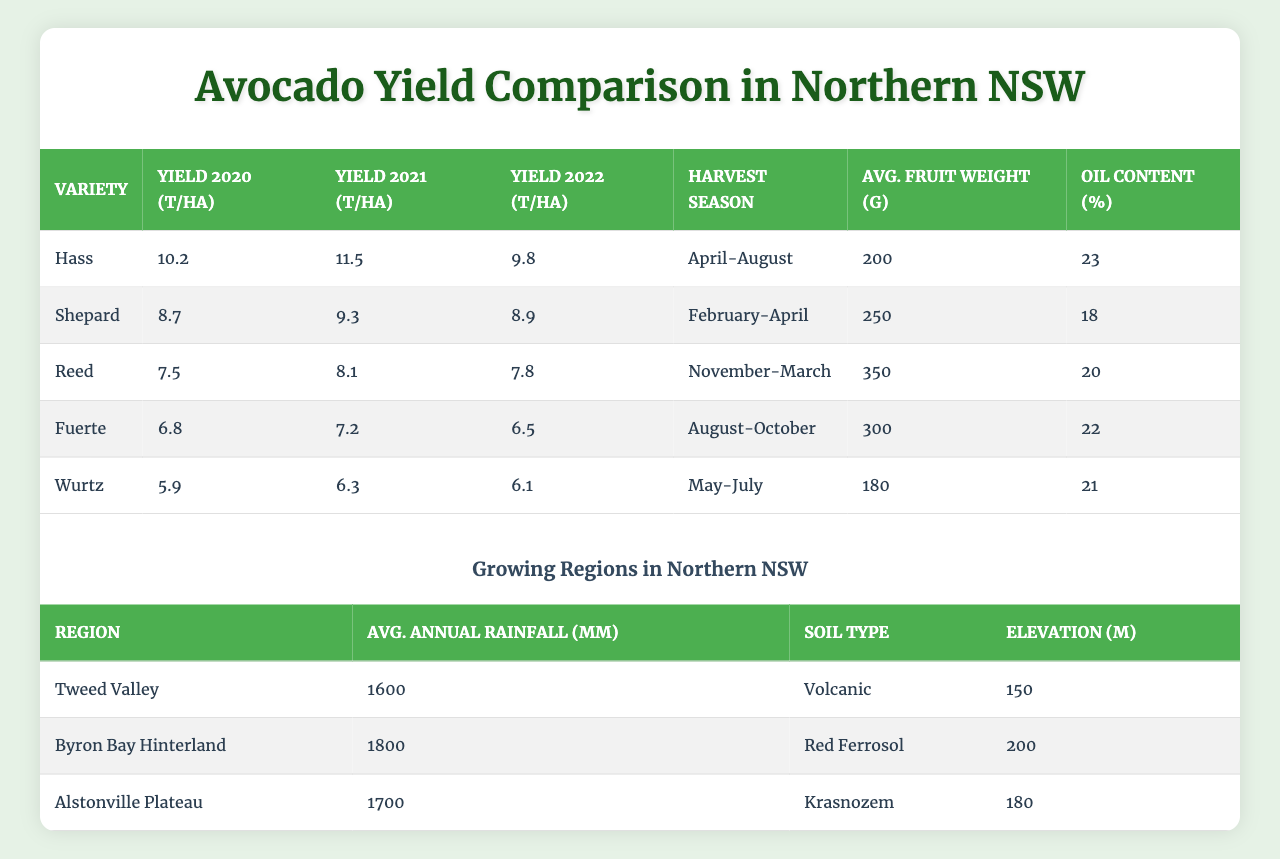What is the yield of the Hass variety in 2021? The table indicates the yield of the Hass variety for 2021 is 11.5 tonnes per hectare.
Answer: 11.5 tonnes per hectare Which variety has the highest average fruit weight? By comparing the average fruit weights in the table, Reed has the highest average fruit weight of 350 grams.
Answer: Reed What is the average yield of the Shepard variety over the three years? To find the average yield of the Shepard variety, we sum the yields for 2020, 2021, and 2022, which is (8.7 + 9.3 + 8.9) = 26.9. Then, we divide by 3 to get the average: 26.9 / 3 = 8.97 tonnes per hectare.
Answer: 8.97 tonnes per hectare Is the oil content of Fuerte avocado higher than that of Shepard? The oil content of Fuerte is 22%, while that of Shepard is 18%. Since 22% is greater than 18%, the statement is true.
Answer: Yes Which avocado variety had the lowest yield in 2022? By looking at the yields for 2022 in the table, Wurtz had the lowest yield of 6.1 tonnes per hectare.
Answer: Wurtz What is the difference in yield between Hass and Fuerte in 2020? The yield of Hass in 2020 was 10.2 tonnes per hectare, while Fuerte had 6.8 tonnes per hectare. The difference is 10.2 - 6.8 = 3.4 tonnes per hectare.
Answer: 3.4 tonnes per hectare Which region has the highest average annual rainfall? Comparing the average annual rainfall in the table, Byron Bay Hinterland has the highest rainfall at 1800 mm.
Answer: Byron Bay Hinterland What is the combined yield of all avocado varieties in 2021? To find the combined yield of all varieties in 2021, we sum the individual yields: 11.5 (Hass) + 9.3 (Shepard) + 8.1 (Reed) + 7.2 (Fuerte) + 6.3 (Wurtz) = 42.4 tonnes per hectare.
Answer: 42.4 tonnes per hectare Is it true that all avocado varieties have an oil content of at least 20%? Checking the oil contents in the table, Fuerte and Shepard have 22% and 18%, respectively, so not all varieties exceed 20%. Therefore, the statement is false.
Answer: No What is the average elevation of the growing regions listed? To find the average elevation, we add the elevations of the regions: 150 + 200 + 180 = 530 meters. Then divide by 3 (the number of regions): 530 / 3 = 176.67 meters.
Answer: 176.67 meters 